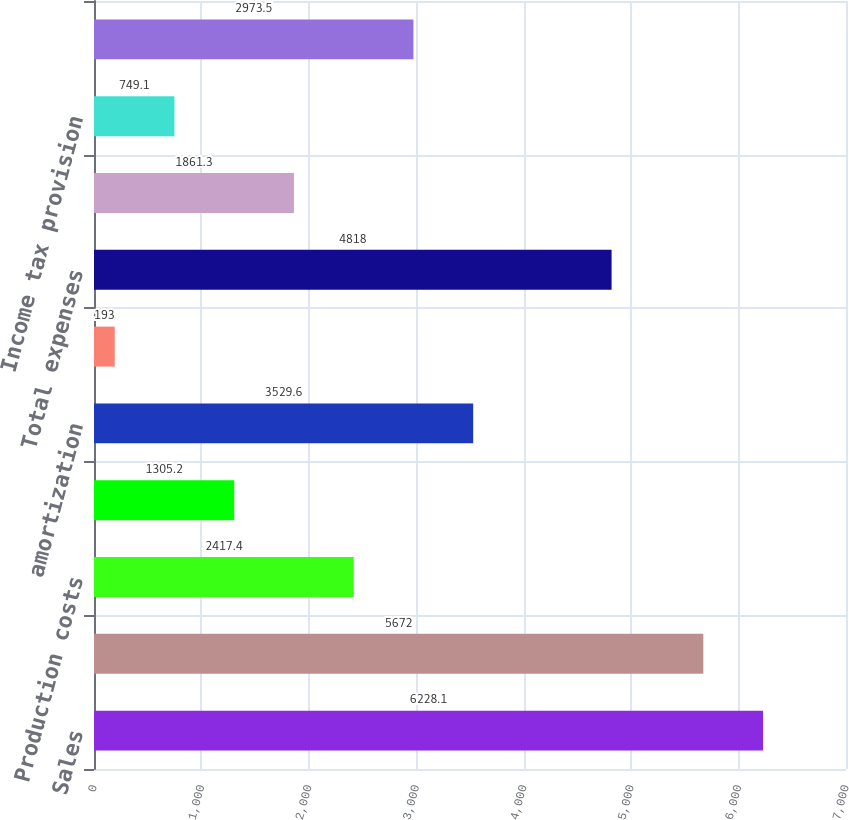Convert chart. <chart><loc_0><loc_0><loc_500><loc_500><bar_chart><fcel>Sales<fcel>Total revenues and other<fcel>Production costs<fcel>Exploration expenses<fcel>amortization<fcel>Technical support and other<fcel>Total expenses<fcel>Results before income taxes<fcel>Income tax provision<fcel>amortization (c)<nl><fcel>6228.1<fcel>5672<fcel>2417.4<fcel>1305.2<fcel>3529.6<fcel>193<fcel>4818<fcel>1861.3<fcel>749.1<fcel>2973.5<nl></chart> 